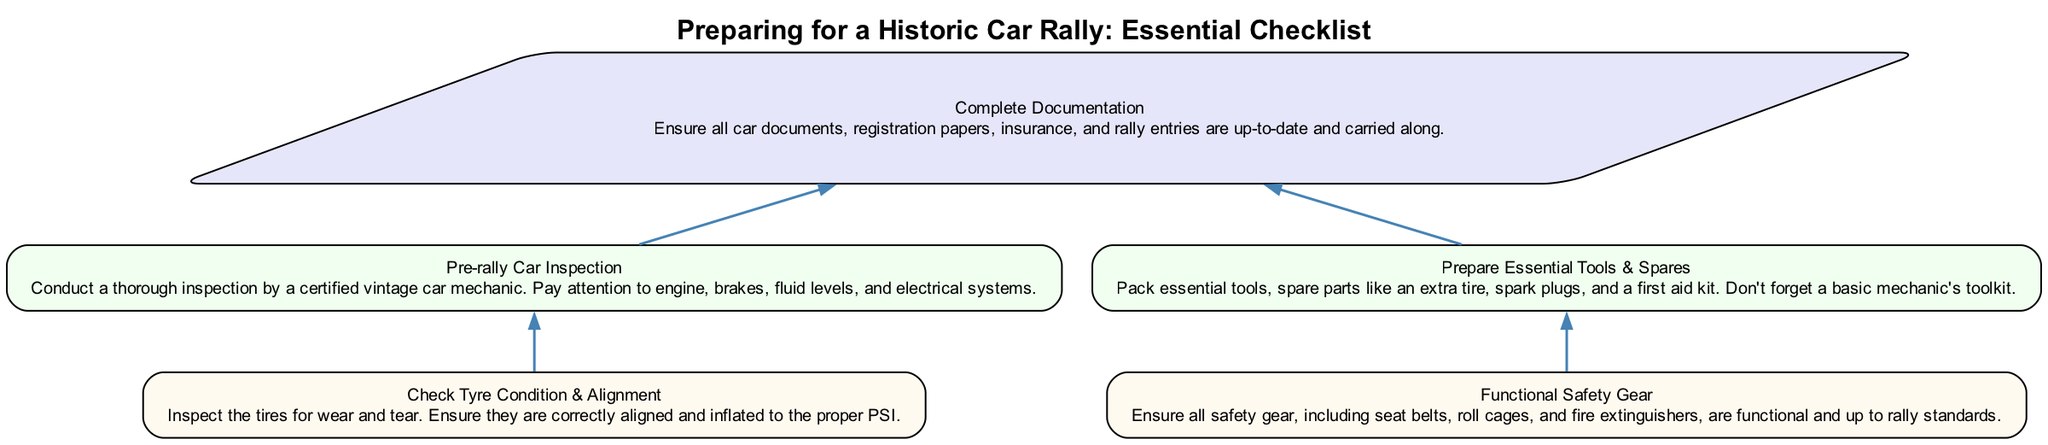What is the top node in the diagram? The top node in the diagram is labeled "Complete Documentation," which indicates that ensuring all car documents are up-to-date is a primary requirement.
Answer: Complete Documentation How many nodes are in Tier 1? Tier 1 contains two nodes: "Pre-rally Car Inspection" and "Prepare Essential Tools & Spares." Counting these provides the total.
Answer: 2 What is the main focus of "Pre-rally Car Inspection"? The details of this node specify that the main focus is on conducting a thorough inspection by a certified vintage car mechanic, emphasizing engine, brakes, and electrical systems.
Answer: Engine, brakes, fluid levels, and electrical systems What is required before "Complete Documentation"? The "Complete Documentation" node does not have a prerequisite and stands at the top. Therefore, it does not require anything before it.
Answer: Nothing How many edges connect the Tier 1 nodes to the base? Each Tier 1 node has one edge connecting to the base, making a total of two edges in this structure linking them to "Complete Documentation."
Answer: 2 What is the relationship between "Check Tyre Condition & Alignment" and "Pre-rally Car Inspection"? "Check Tyre Condition & Alignment" is a Tier 2 node that is directly connected to one of the Tier 1 nodes, which is "Pre-rally Car Inspection." This indicates that checking tire conditions is part of the pre-rally inspection process.
Answer: Part of the pre-rally inspection What type of node is "Functional Safety Gear"? The node "Functional Safety Gear" is categorized as a Tier 2 node in the diagram, representing a necessary step in preparing for the rally. Tier 2 nodes provide further detail on requirements under the Tier 1 processes.
Answer: Tier 2 node What must be ensured regarding safety gear? The description under the node specifies that ensuring all safety gear is functional and meets rally standards is a primary requirement outlined in this checklist.
Answer: Functional and up to rally standards Which checklist item emphasizes packing tools and spare parts? The node titled "Prepare Essential Tools & Spares" explicitly highlights the importance of packing essential tools and spare parts to be prepared for the rally.
Answer: Prepare Essential Tools & Spares 